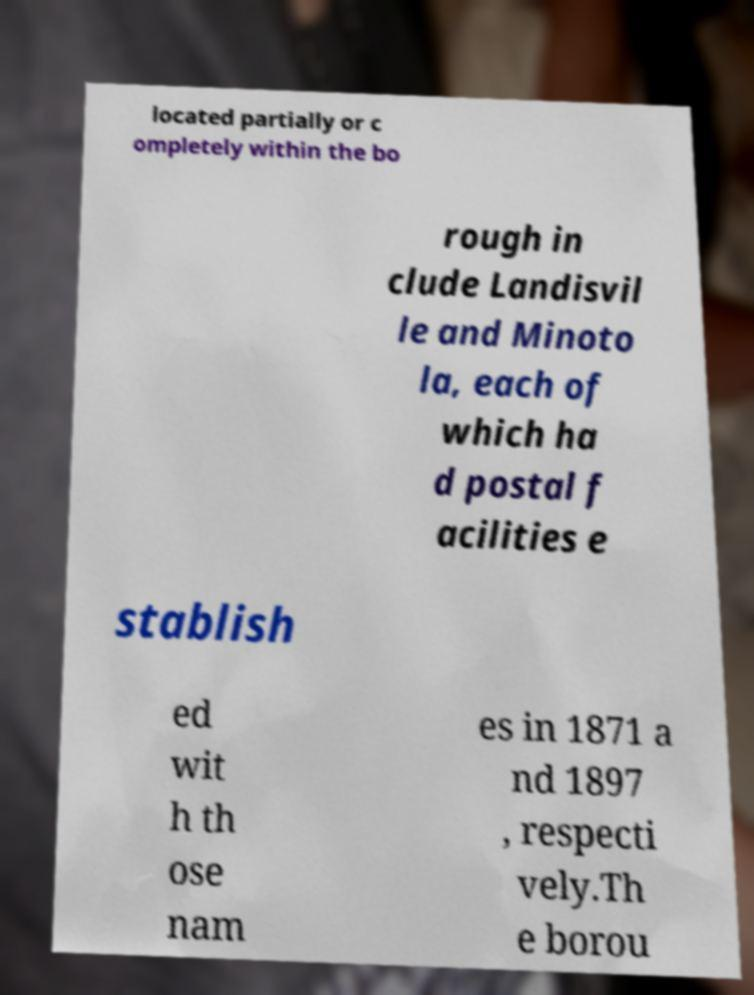There's text embedded in this image that I need extracted. Can you transcribe it verbatim? located partially or c ompletely within the bo rough in clude Landisvil le and Minoto la, each of which ha d postal f acilities e stablish ed wit h th ose nam es in 1871 a nd 1897 , respecti vely.Th e borou 